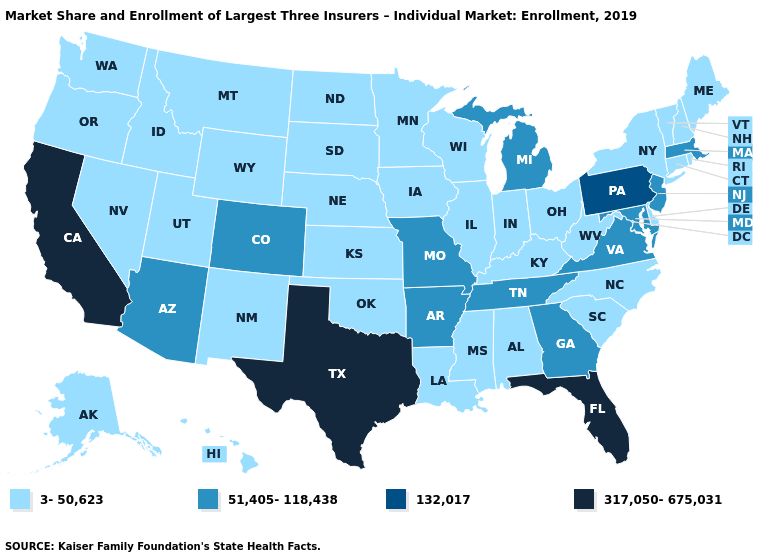Name the states that have a value in the range 132,017?
Answer briefly. Pennsylvania. Does Pennsylvania have the highest value in the Northeast?
Concise answer only. Yes. Does Maine have the lowest value in the USA?
Keep it brief. Yes. Name the states that have a value in the range 132,017?
Answer briefly. Pennsylvania. Name the states that have a value in the range 3-50,623?
Give a very brief answer. Alabama, Alaska, Connecticut, Delaware, Hawaii, Idaho, Illinois, Indiana, Iowa, Kansas, Kentucky, Louisiana, Maine, Minnesota, Mississippi, Montana, Nebraska, Nevada, New Hampshire, New Mexico, New York, North Carolina, North Dakota, Ohio, Oklahoma, Oregon, Rhode Island, South Carolina, South Dakota, Utah, Vermont, Washington, West Virginia, Wisconsin, Wyoming. Which states hav the highest value in the West?
Keep it brief. California. Which states have the highest value in the USA?
Quick response, please. California, Florida, Texas. What is the value of Nevada?
Give a very brief answer. 3-50,623. Which states hav the highest value in the MidWest?
Quick response, please. Michigan, Missouri. Which states have the lowest value in the West?
Give a very brief answer. Alaska, Hawaii, Idaho, Montana, Nevada, New Mexico, Oregon, Utah, Washington, Wyoming. How many symbols are there in the legend?
Write a very short answer. 4. What is the value of North Carolina?
Give a very brief answer. 3-50,623. Does the map have missing data?
Answer briefly. No. Name the states that have a value in the range 3-50,623?
Answer briefly. Alabama, Alaska, Connecticut, Delaware, Hawaii, Idaho, Illinois, Indiana, Iowa, Kansas, Kentucky, Louisiana, Maine, Minnesota, Mississippi, Montana, Nebraska, Nevada, New Hampshire, New Mexico, New York, North Carolina, North Dakota, Ohio, Oklahoma, Oregon, Rhode Island, South Carolina, South Dakota, Utah, Vermont, Washington, West Virginia, Wisconsin, Wyoming. Name the states that have a value in the range 132,017?
Write a very short answer. Pennsylvania. 